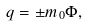<formula> <loc_0><loc_0><loc_500><loc_500>q = \pm m _ { 0 } \Phi ,</formula> 